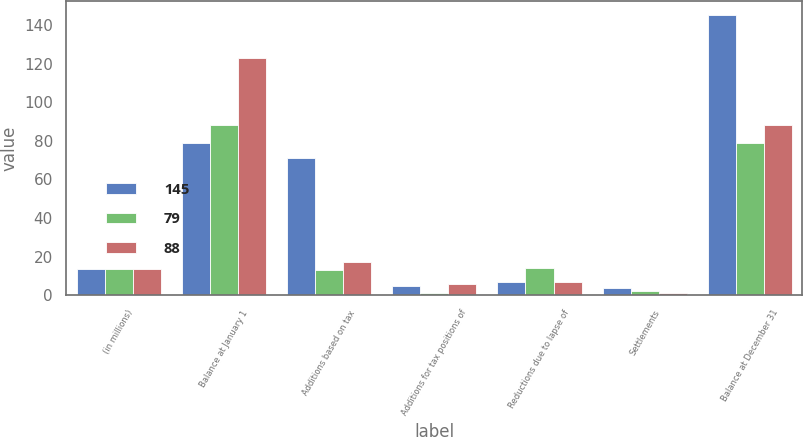Convert chart to OTSL. <chart><loc_0><loc_0><loc_500><loc_500><stacked_bar_chart><ecel><fcel>(in millions)<fcel>Balance at January 1<fcel>Additions based on tax<fcel>Additions for tax positions of<fcel>Reductions due to lapse of<fcel>Settlements<fcel>Balance at December 31<nl><fcel>145<fcel>13.5<fcel>79<fcel>71<fcel>5<fcel>7<fcel>4<fcel>145<nl><fcel>79<fcel>13.5<fcel>88<fcel>13<fcel>1<fcel>14<fcel>2<fcel>79<nl><fcel>88<fcel>13.5<fcel>123<fcel>17<fcel>6<fcel>7<fcel>1<fcel>88<nl></chart> 